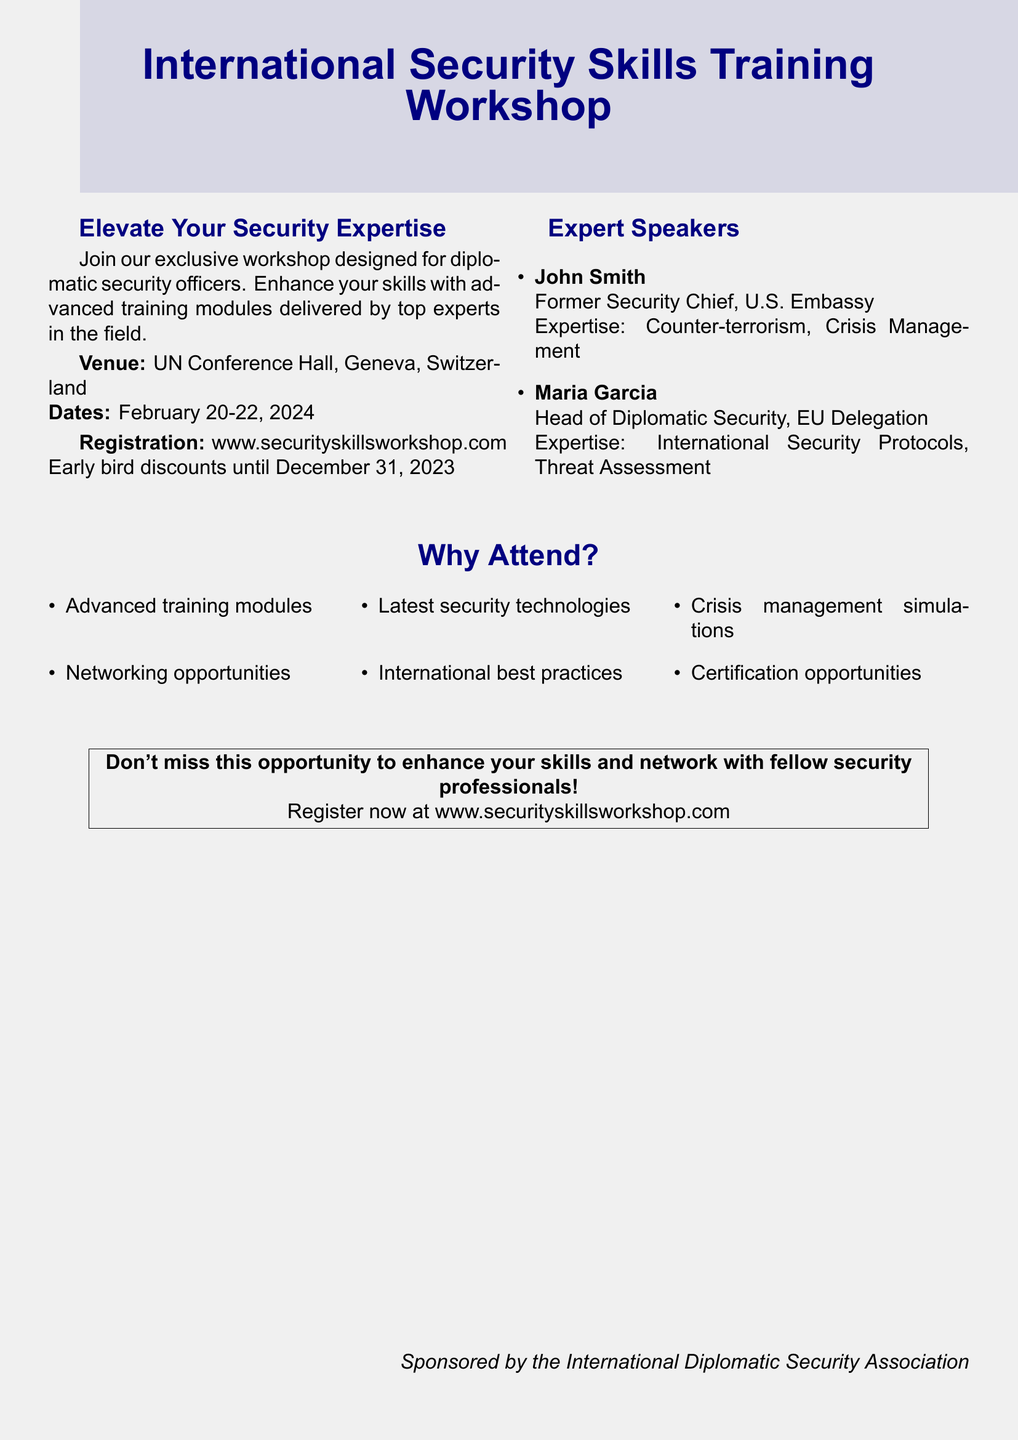What are the dates of the workshop? The workshop is scheduled for February 20-22, 2024.
Answer: February 20-22, 2024 Who is one of the expert speakers? The document lists John Smith as an expert speaker and former Security Chief at the U.S. Embassy.
Answer: John Smith What is the venue for the workshop? The venue for the workshop is stated as the UN Conference Hall in Geneva, Switzerland.
Answer: UN Conference Hall, Geneva, Switzerland What is the early bird registration deadline? The early bird registration deadline for discounts is December 31, 2023.
Answer: December 31, 2023 What type of professionals is the workshop targeted at? The workshop is specifically designed for diplomatic security officers, as mentioned in the document.
Answer: Diplomatic security officers How many expert speakers are mentioned in the document? There are two expert speakers listed in the document: John Smith and Maria Garcia.
Answer: Two What is one of the benefits of attending the workshop? The document highlights advanced training modules as a key benefit of attending the workshop.
Answer: Advanced training modules What title does Maria Garcia hold? Maria Garcia is the Head of Diplomatic Security at the EU Delegation according to the document.
Answer: Head of Diplomatic Security What organization sponsors the workshop? The workshop is sponsored by the International Diplomatic Security Association.
Answer: International Diplomatic Security Association 